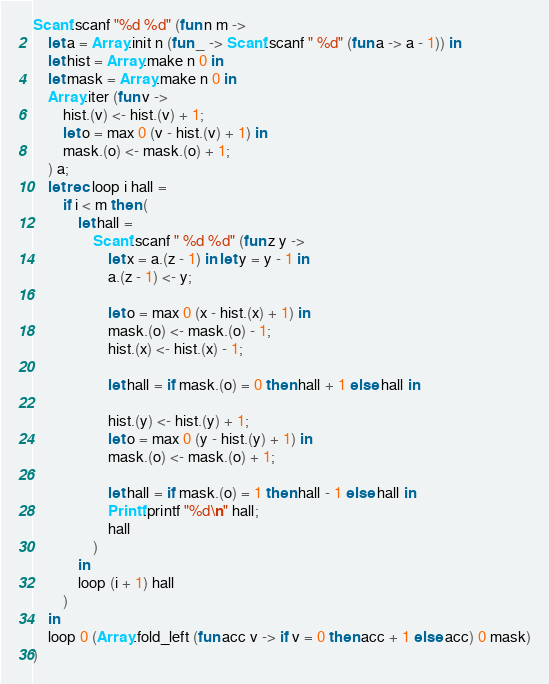Convert code to text. <code><loc_0><loc_0><loc_500><loc_500><_OCaml_>Scanf.scanf "%d %d" (fun n m ->
    let a = Array.init n (fun _ -> Scanf.scanf " %d" (fun a -> a - 1)) in
    let hist = Array.make n 0 in
    let mask = Array.make n 0 in
    Array.iter (fun v ->
        hist.(v) <- hist.(v) + 1;
        let o = max 0 (v - hist.(v) + 1) in
        mask.(o) <- mask.(o) + 1;
    ) a;
    let rec loop i hall =
        if i < m then (
            let hall =
                Scanf.scanf " %d %d" (fun z y ->
                    let x = a.(z - 1) in let y = y - 1 in
                    a.(z - 1) <- y;

                    let o = max 0 (x - hist.(x) + 1) in
                    mask.(o) <- mask.(o) - 1;
                    hist.(x) <- hist.(x) - 1;

                    let hall = if mask.(o) = 0 then hall + 1 else hall in

                    hist.(y) <- hist.(y) + 1;
                    let o = max 0 (y - hist.(y) + 1) in
                    mask.(o) <- mask.(o) + 1;
                    
                    let hall = if mask.(o) = 1 then hall - 1 else hall in
                    Printf.printf "%d\n" hall;
                    hall
                )
            in
            loop (i + 1) hall
        )
    in
    loop 0 (Array.fold_left (fun acc v -> if v = 0 then acc + 1 else acc) 0 mask)
)</code> 